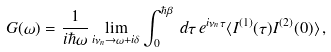<formula> <loc_0><loc_0><loc_500><loc_500>G ( \omega ) = \frac { 1 } { i \hbar { \omega } } \lim _ { i \nu _ { n } \rightarrow \omega + i \delta } \int ^ { \hbar { \beta } } _ { 0 } \, d \tau \, e ^ { i \nu _ { n } \tau } \langle I ^ { ( 1 ) } ( \tau ) I ^ { ( 2 ) } ( 0 ) \rangle \, ,</formula> 